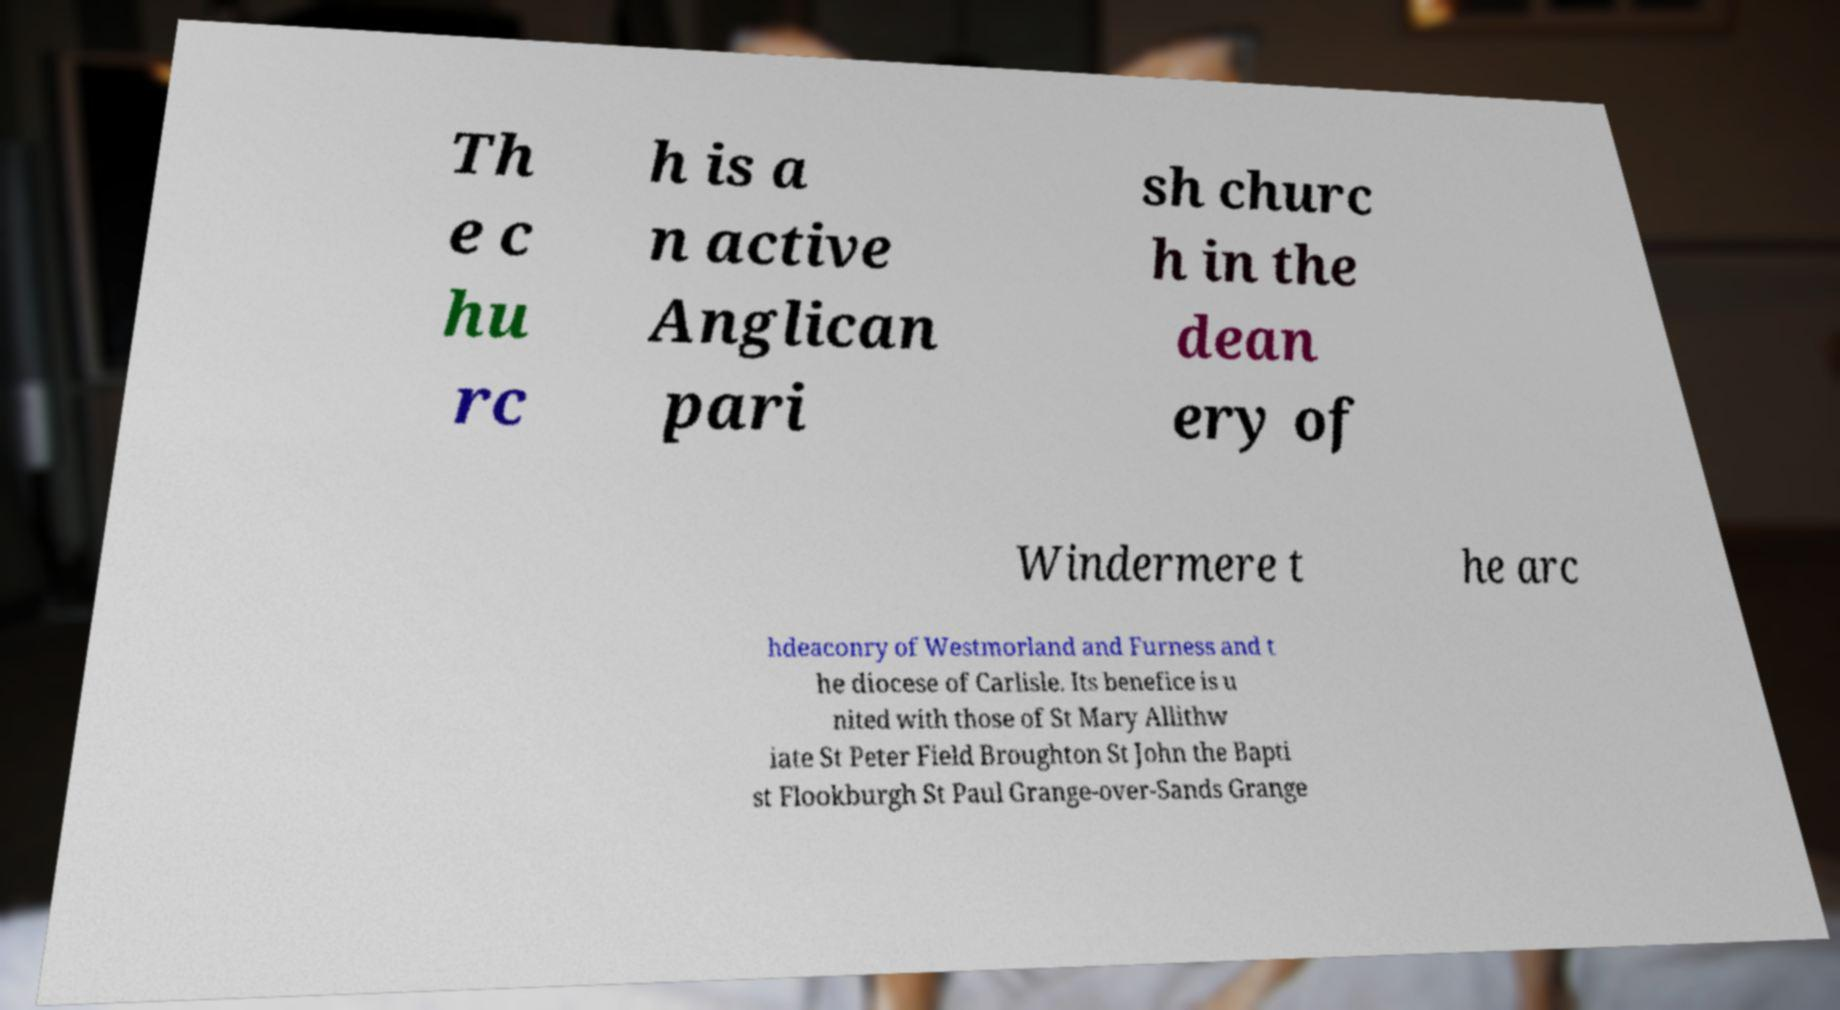Please identify and transcribe the text found in this image. Th e c hu rc h is a n active Anglican pari sh churc h in the dean ery of Windermere t he arc hdeaconry of Westmorland and Furness and t he diocese of Carlisle. Its benefice is u nited with those of St Mary Allithw iate St Peter Field Broughton St John the Bapti st Flookburgh St Paul Grange-over-Sands Grange 